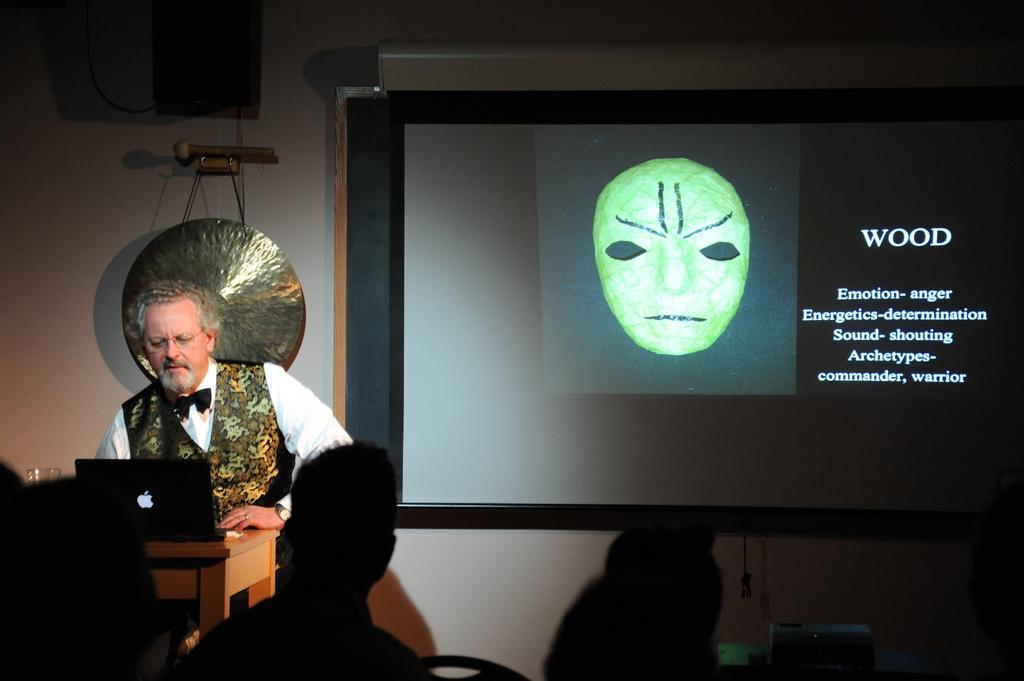How would you summarize this image in a sentence or two? In this image I can see a man and here on this table I can see a laptop. In the background I can see projector screen and on this screen I can see something is written. I can also see this image is little bit in dark. 